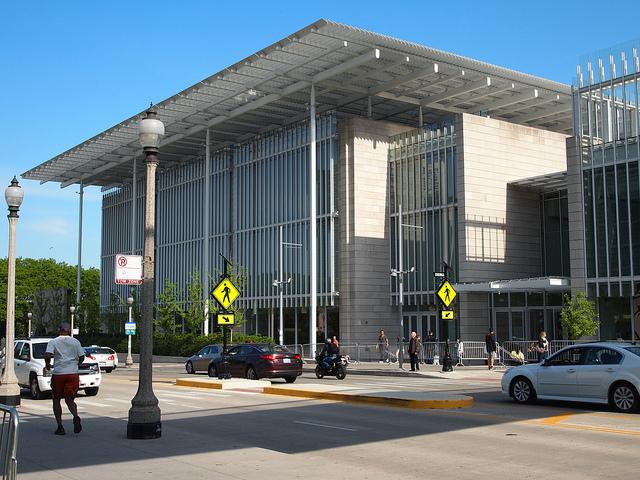Is it sunny?
Be succinct. Yes. What color are the street signs?
Quick response, please. Yellow. Are there any clouds in the sky?
Quick response, please. No. 